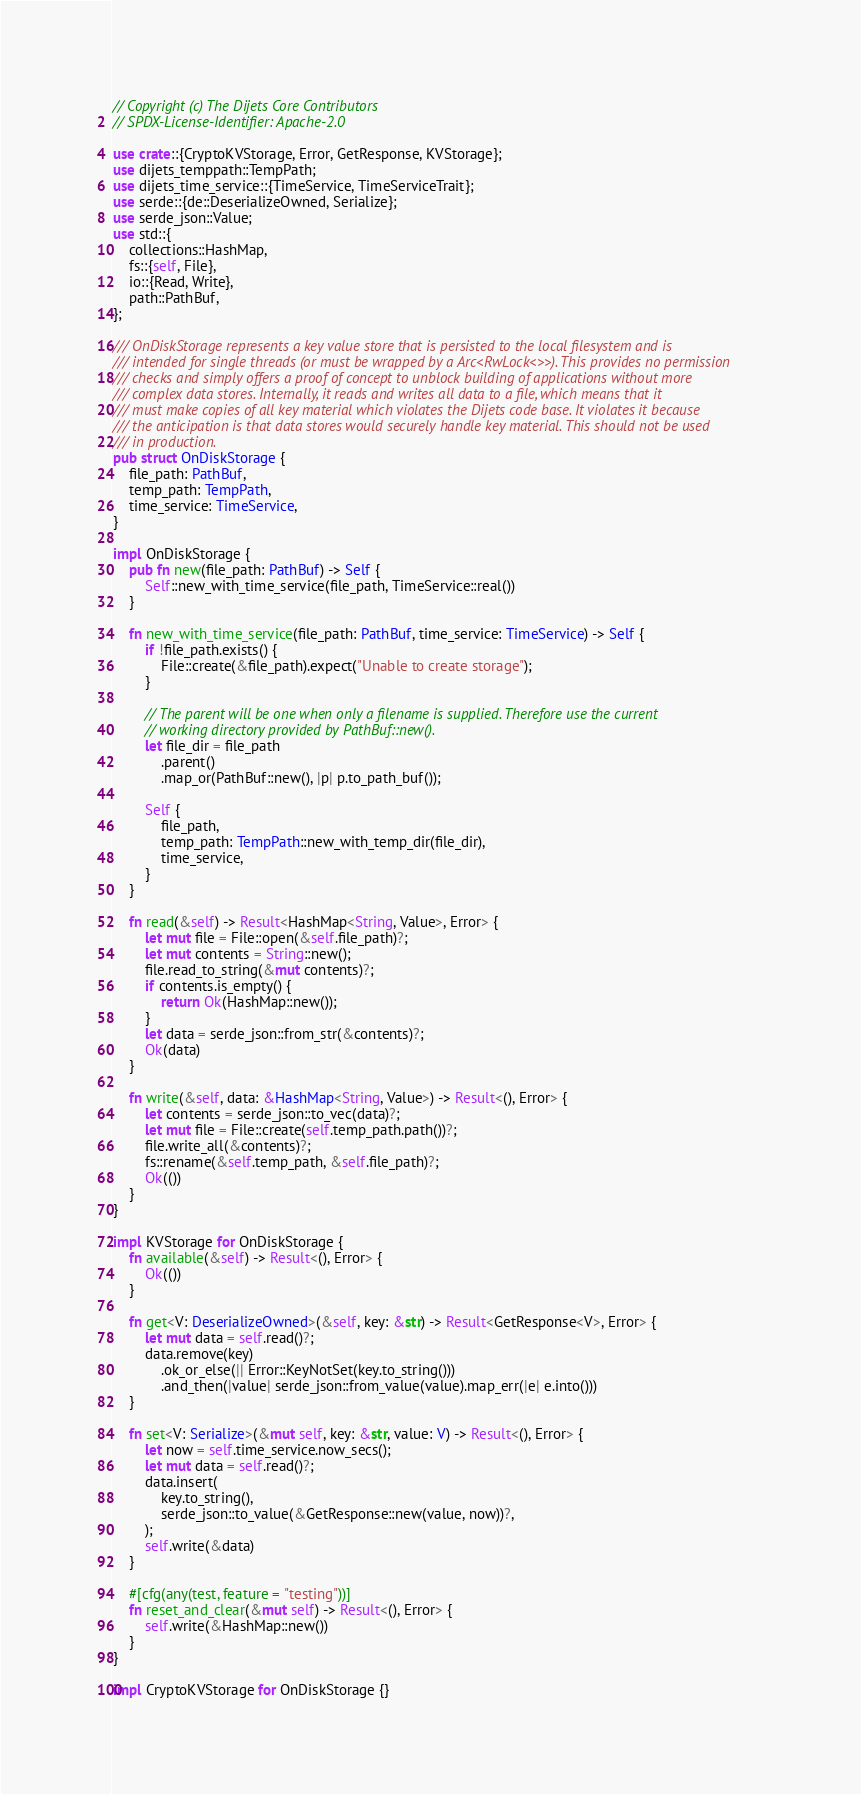Convert code to text. <code><loc_0><loc_0><loc_500><loc_500><_Rust_>// Copyright (c) The Dijets Core Contributors
// SPDX-License-Identifier: Apache-2.0

use crate::{CryptoKVStorage, Error, GetResponse, KVStorage};
use dijets_temppath::TempPath;
use dijets_time_service::{TimeService, TimeServiceTrait};
use serde::{de::DeserializeOwned, Serialize};
use serde_json::Value;
use std::{
    collections::HashMap,
    fs::{self, File},
    io::{Read, Write},
    path::PathBuf,
};

/// OnDiskStorage represents a key value store that is persisted to the local filesystem and is
/// intended for single threads (or must be wrapped by a Arc<RwLock<>>). This provides no permission
/// checks and simply offers a proof of concept to unblock building of applications without more
/// complex data stores. Internally, it reads and writes all data to a file, which means that it
/// must make copies of all key material which violates the Dijets code base. It violates it because
/// the anticipation is that data stores would securely handle key material. This should not be used
/// in production.
pub struct OnDiskStorage {
    file_path: PathBuf,
    temp_path: TempPath,
    time_service: TimeService,
}

impl OnDiskStorage {
    pub fn new(file_path: PathBuf) -> Self {
        Self::new_with_time_service(file_path, TimeService::real())
    }

    fn new_with_time_service(file_path: PathBuf, time_service: TimeService) -> Self {
        if !file_path.exists() {
            File::create(&file_path).expect("Unable to create storage");
        }

        // The parent will be one when only a filename is supplied. Therefore use the current
        // working directory provided by PathBuf::new().
        let file_dir = file_path
            .parent()
            .map_or(PathBuf::new(), |p| p.to_path_buf());

        Self {
            file_path,
            temp_path: TempPath::new_with_temp_dir(file_dir),
            time_service,
        }
    }

    fn read(&self) -> Result<HashMap<String, Value>, Error> {
        let mut file = File::open(&self.file_path)?;
        let mut contents = String::new();
        file.read_to_string(&mut contents)?;
        if contents.is_empty() {
            return Ok(HashMap::new());
        }
        let data = serde_json::from_str(&contents)?;
        Ok(data)
    }

    fn write(&self, data: &HashMap<String, Value>) -> Result<(), Error> {
        let contents = serde_json::to_vec(data)?;
        let mut file = File::create(self.temp_path.path())?;
        file.write_all(&contents)?;
        fs::rename(&self.temp_path, &self.file_path)?;
        Ok(())
    }
}

impl KVStorage for OnDiskStorage {
    fn available(&self) -> Result<(), Error> {
        Ok(())
    }

    fn get<V: DeserializeOwned>(&self, key: &str) -> Result<GetResponse<V>, Error> {
        let mut data = self.read()?;
        data.remove(key)
            .ok_or_else(|| Error::KeyNotSet(key.to_string()))
            .and_then(|value| serde_json::from_value(value).map_err(|e| e.into()))
    }

    fn set<V: Serialize>(&mut self, key: &str, value: V) -> Result<(), Error> {
        let now = self.time_service.now_secs();
        let mut data = self.read()?;
        data.insert(
            key.to_string(),
            serde_json::to_value(&GetResponse::new(value, now))?,
        );
        self.write(&data)
    }

    #[cfg(any(test, feature = "testing"))]
    fn reset_and_clear(&mut self) -> Result<(), Error> {
        self.write(&HashMap::new())
    }
}

impl CryptoKVStorage for OnDiskStorage {}
</code> 